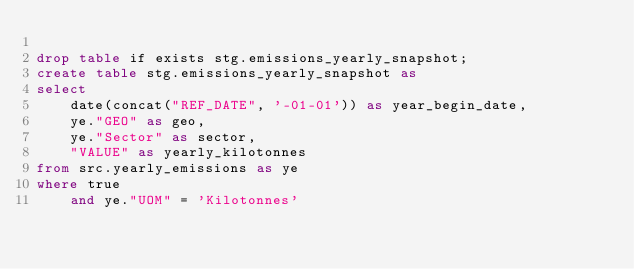Convert code to text. <code><loc_0><loc_0><loc_500><loc_500><_SQL_>
drop table if exists stg.emissions_yearly_snapshot;
create table stg.emissions_yearly_snapshot as 
select 
	date(concat("REF_DATE", '-01-01')) as year_begin_date,
	ye."GEO" as geo,
	ye."Sector" as sector,
	"VALUE" as yearly_kilotonnes
from src.yearly_emissions as ye 
where true 
	and ye."UOM" = 'Kilotonnes'</code> 